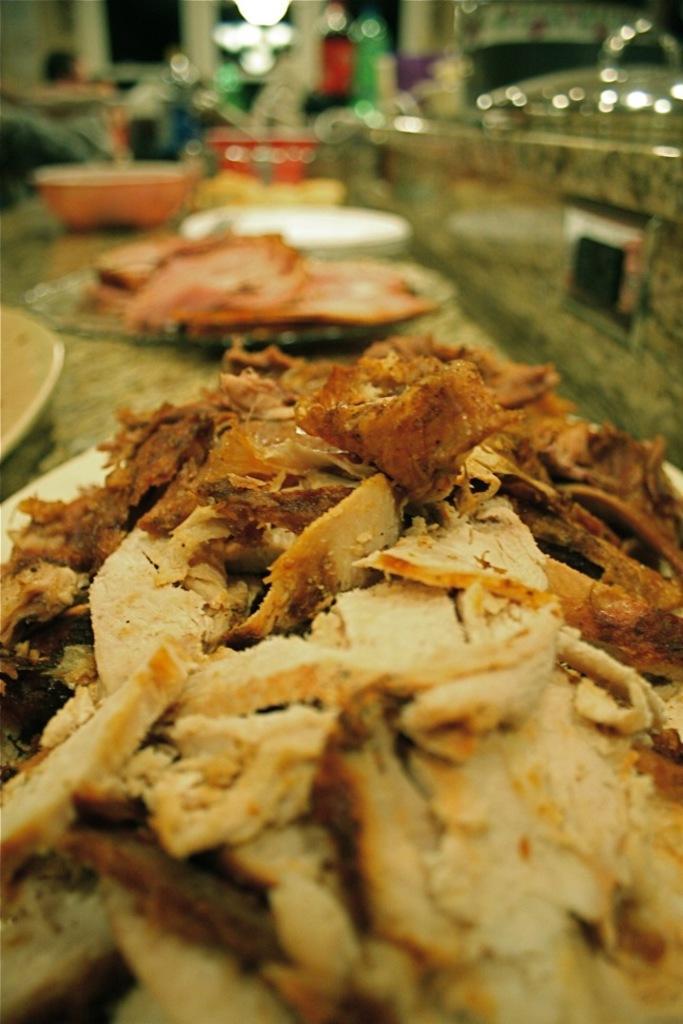Describe this image in one or two sentences. In this image I can see the plates with food. To the side of these plates I can see the bowls. I can see the lights and there is a blurred background. 